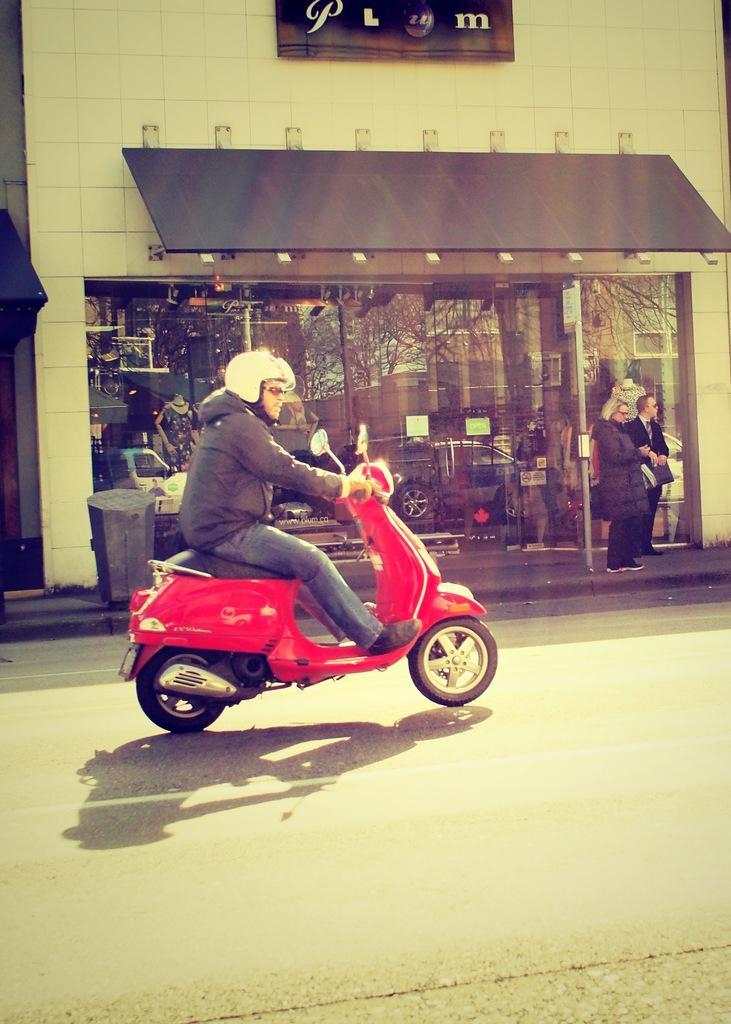How would you summarize this image in a sentence or two? In this image we can see a red color scooter upon which a man is riding by wearing a helmet on his head. In the background of the image we can see a store. where two persons are standing. Through glass we can see a car. 